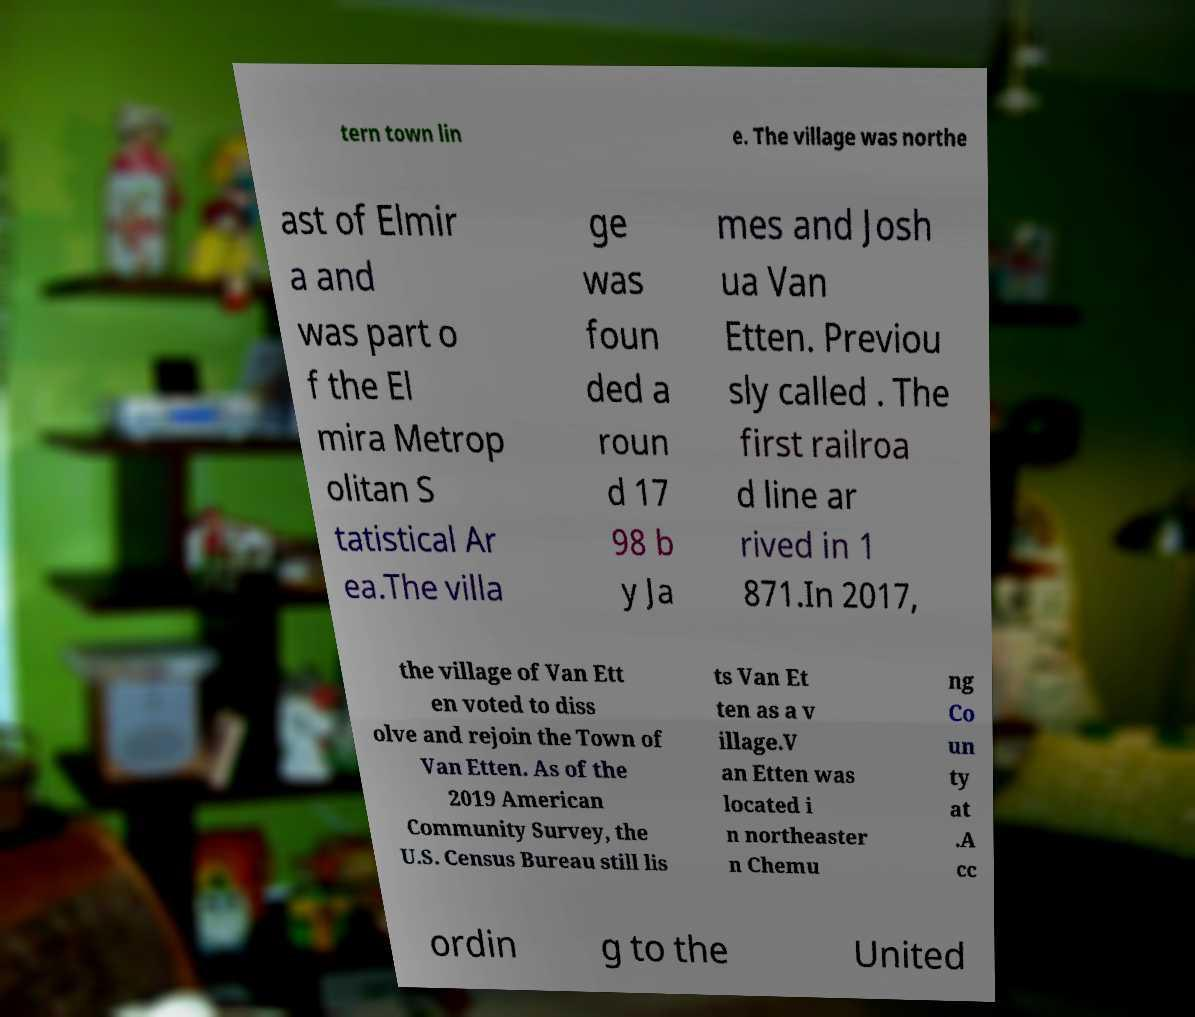Could you extract and type out the text from this image? tern town lin e. The village was northe ast of Elmir a and was part o f the El mira Metrop olitan S tatistical Ar ea.The villa ge was foun ded a roun d 17 98 b y Ja mes and Josh ua Van Etten. Previou sly called . The first railroa d line ar rived in 1 871.In 2017, the village of Van Ett en voted to diss olve and rejoin the Town of Van Etten. As of the 2019 American Community Survey, the U.S. Census Bureau still lis ts Van Et ten as a v illage.V an Etten was located i n northeaster n Chemu ng Co un ty at .A cc ordin g to the United 